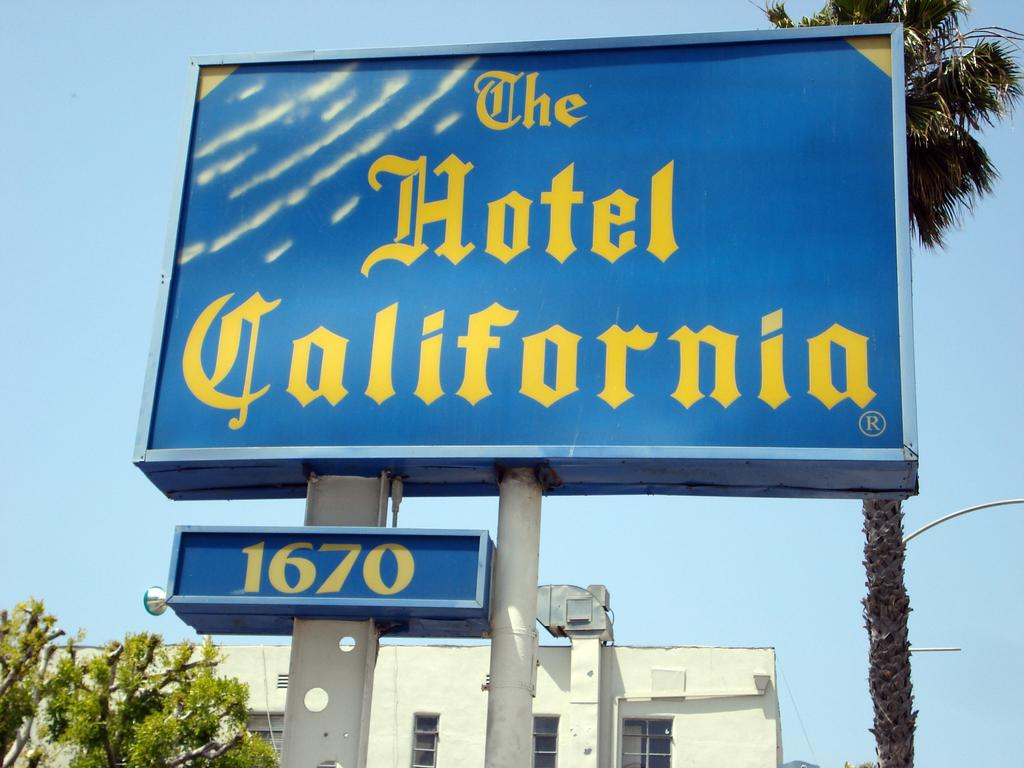<image>
Write a terse but informative summary of the picture. The street number of this hotel is 1670. 